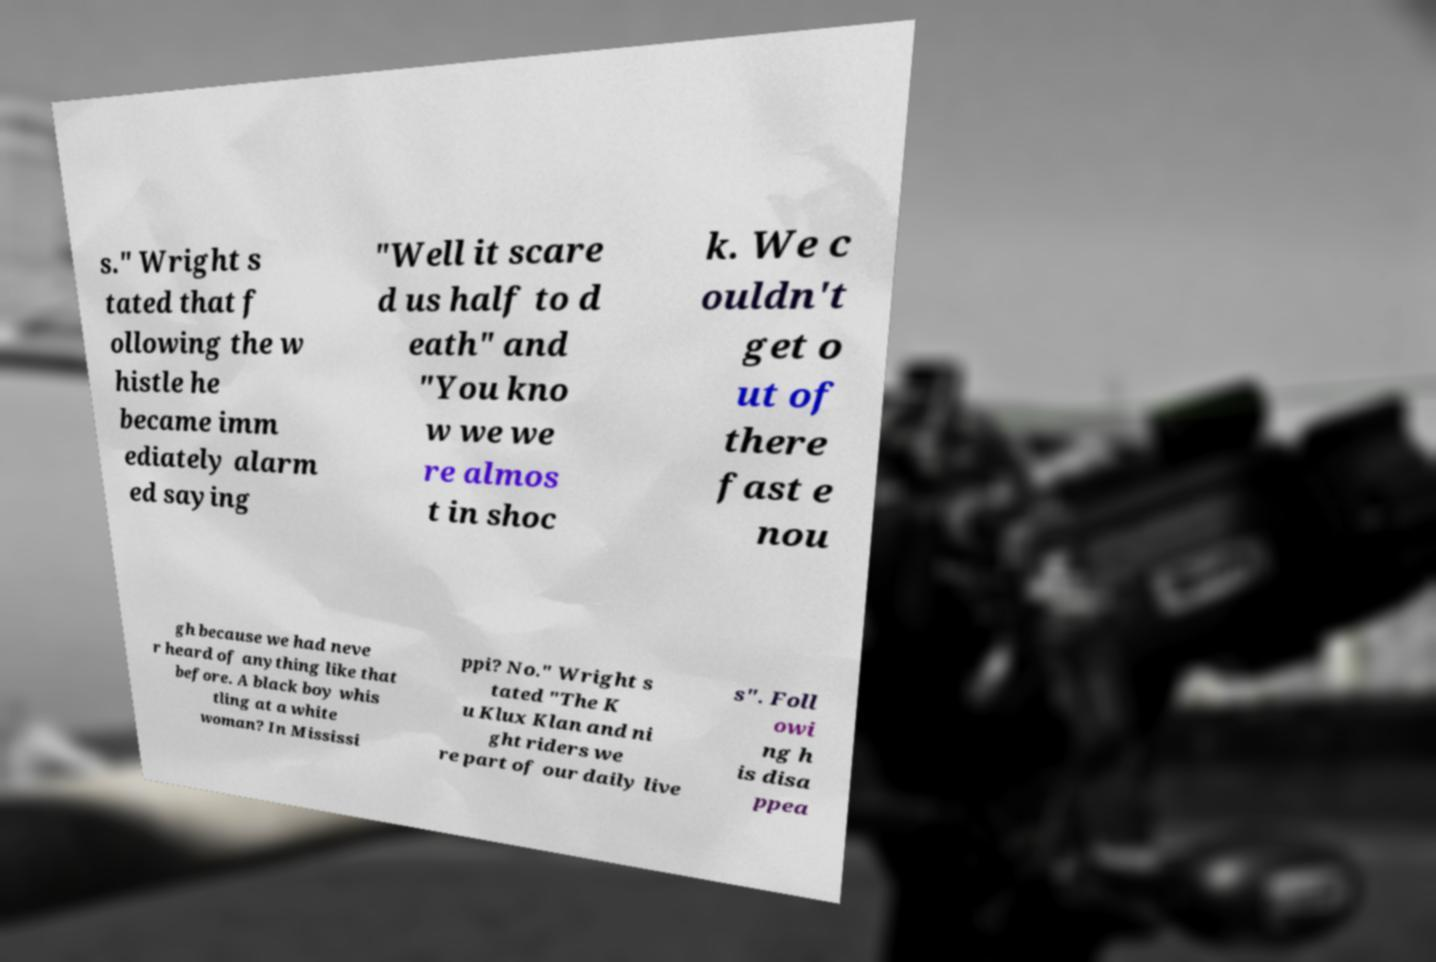What messages or text are displayed in this image? I need them in a readable, typed format. s." Wright s tated that f ollowing the w histle he became imm ediately alarm ed saying "Well it scare d us half to d eath" and "You kno w we we re almos t in shoc k. We c ouldn't get o ut of there fast e nou gh because we had neve r heard of anything like that before. A black boy whis tling at a white woman? In Mississi ppi? No." Wright s tated "The K u Klux Klan and ni ght riders we re part of our daily live s". Foll owi ng h is disa ppea 